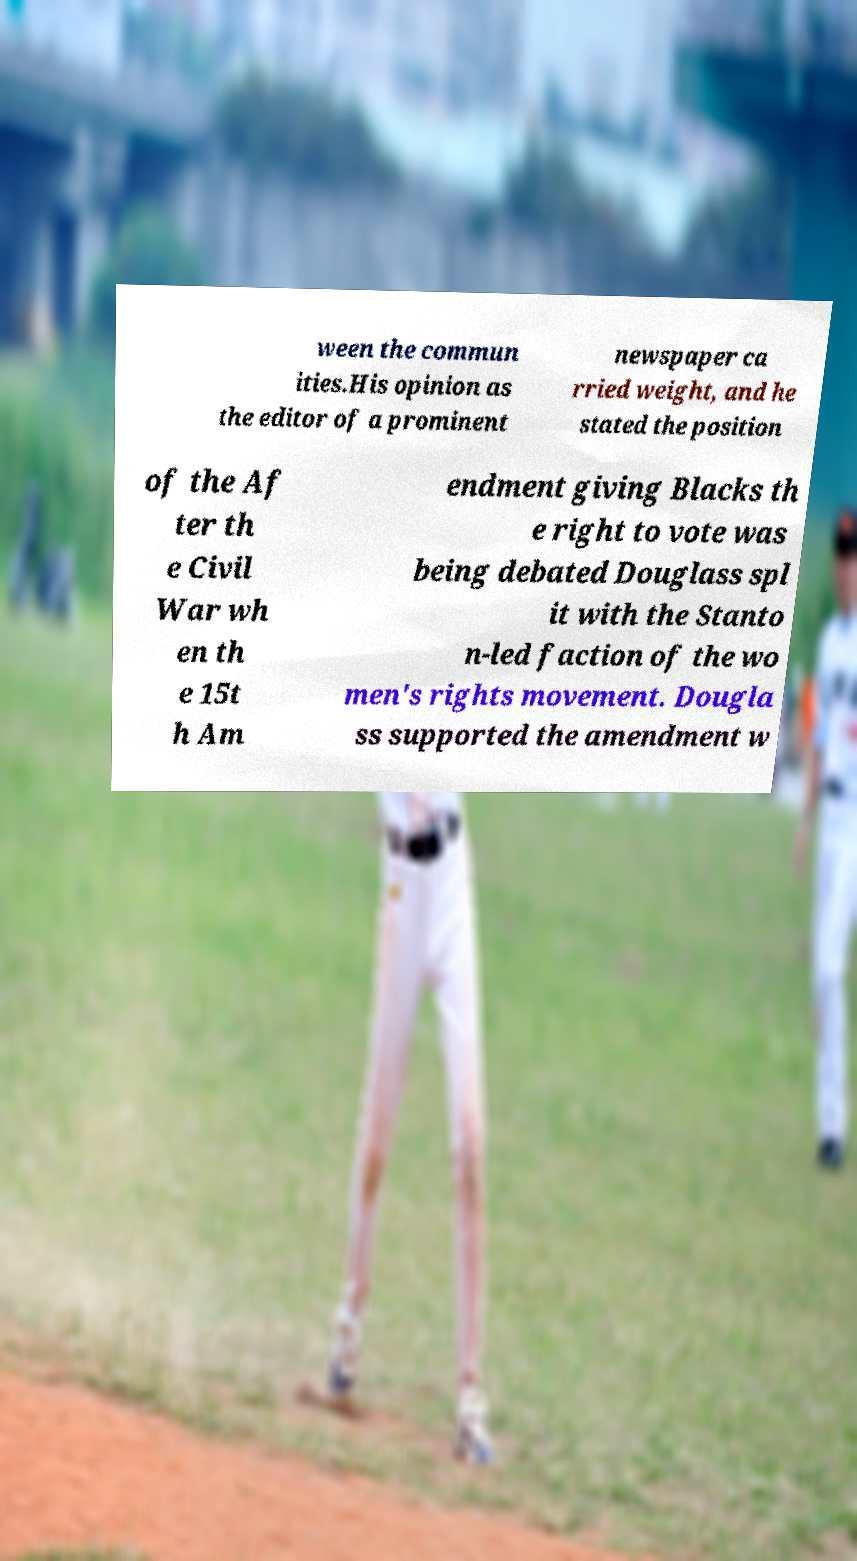Can you accurately transcribe the text from the provided image for me? ween the commun ities.His opinion as the editor of a prominent newspaper ca rried weight, and he stated the position of the Af ter th e Civil War wh en th e 15t h Am endment giving Blacks th e right to vote was being debated Douglass spl it with the Stanto n-led faction of the wo men's rights movement. Dougla ss supported the amendment w 